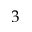Convert formula to latex. <formula><loc_0><loc_0><loc_500><loc_500>3</formula> 